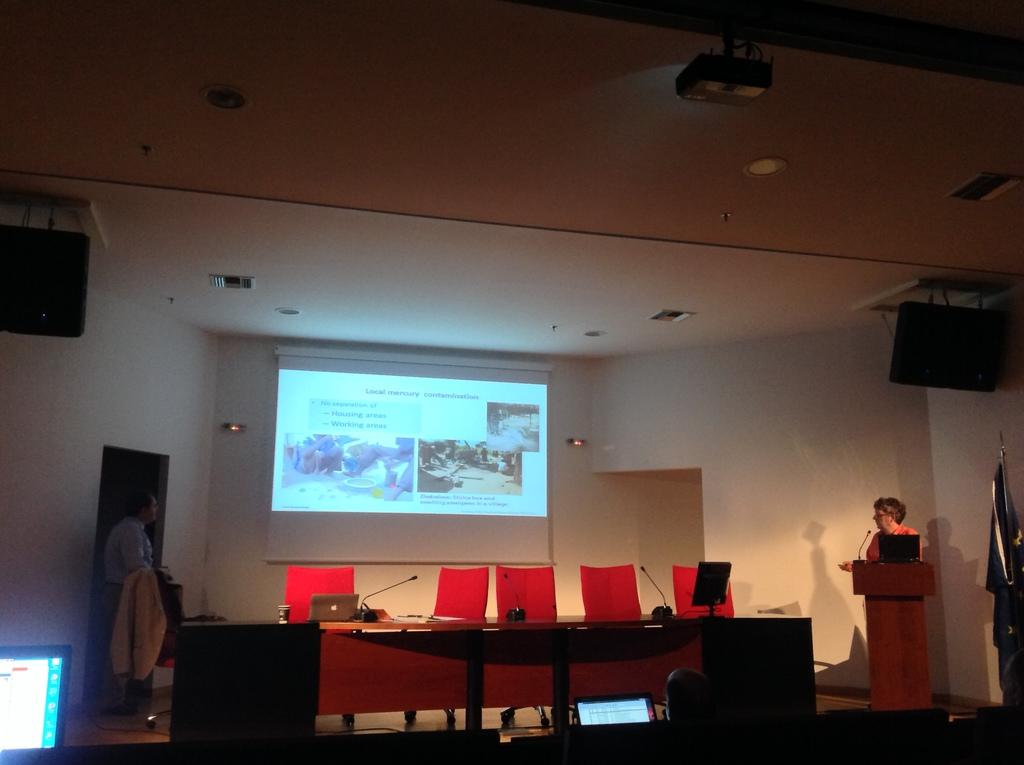What type of space is depicted in the image? The image is of a hall. What furniture is present in the hall? There are chairs in the hall. What can be found on the stage in the image? There is a table on the stage. What is on the wall in the image? There is a projector screen on the wall. What type of equipment is present in the hall? There are speakers in the hall. How many people are on the stage in the image? There are two people on the stage. What type of muscle can be seen flexing on the stage in the image? There is no muscle visible on the stage in the image. Is there a river flowing through the hall in the image? No, there is no river present in the image. 